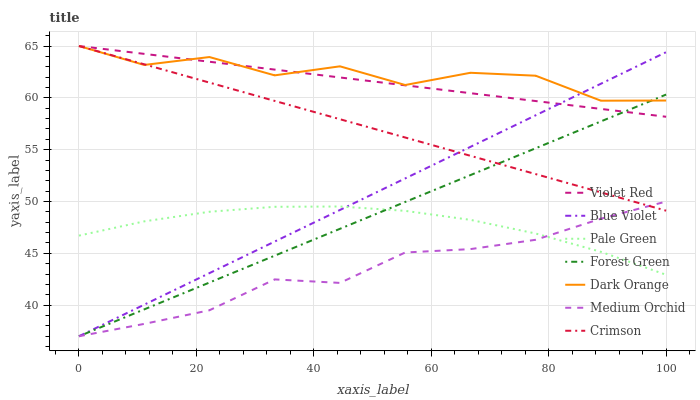Does Medium Orchid have the minimum area under the curve?
Answer yes or no. Yes. Does Dark Orange have the maximum area under the curve?
Answer yes or no. Yes. Does Violet Red have the minimum area under the curve?
Answer yes or no. No. Does Violet Red have the maximum area under the curve?
Answer yes or no. No. Is Forest Green the smoothest?
Answer yes or no. Yes. Is Dark Orange the roughest?
Answer yes or no. Yes. Is Violet Red the smoothest?
Answer yes or no. No. Is Violet Red the roughest?
Answer yes or no. No. Does Medium Orchid have the lowest value?
Answer yes or no. Yes. Does Violet Red have the lowest value?
Answer yes or no. No. Does Crimson have the highest value?
Answer yes or no. Yes. Does Medium Orchid have the highest value?
Answer yes or no. No. Is Pale Green less than Crimson?
Answer yes or no. Yes. Is Violet Red greater than Pale Green?
Answer yes or no. Yes. Does Pale Green intersect Medium Orchid?
Answer yes or no. Yes. Is Pale Green less than Medium Orchid?
Answer yes or no. No. Is Pale Green greater than Medium Orchid?
Answer yes or no. No. Does Pale Green intersect Crimson?
Answer yes or no. No. 